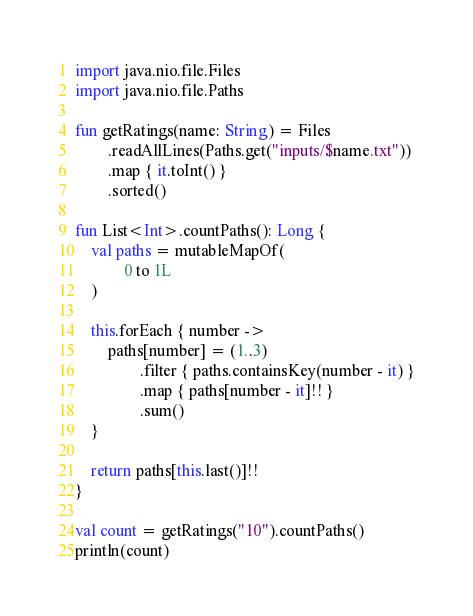<code> <loc_0><loc_0><loc_500><loc_500><_Kotlin_>import java.nio.file.Files
import java.nio.file.Paths

fun getRatings(name: String) = Files
        .readAllLines(Paths.get("inputs/$name.txt"))
        .map { it.toInt() }
        .sorted()

fun List<Int>.countPaths(): Long {
    val paths = mutableMapOf(
            0 to 1L
    )

    this.forEach { number ->
        paths[number] = (1..3)
                .filter { paths.containsKey(number - it) }
                .map { paths[number - it]!! }
                .sum()
    }

    return paths[this.last()]!!
}

val count = getRatings("10").countPaths()
println(count)</code> 